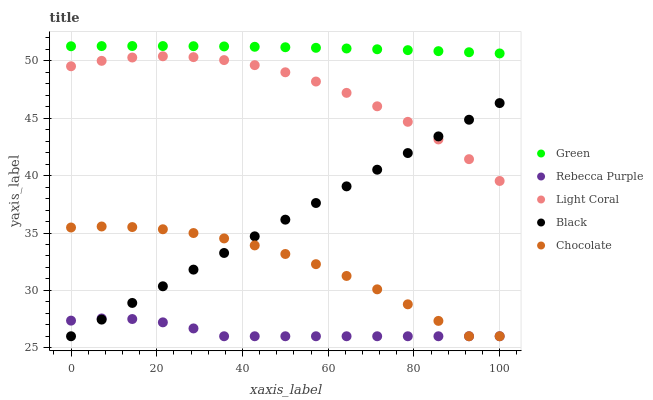Does Rebecca Purple have the minimum area under the curve?
Answer yes or no. Yes. Does Green have the maximum area under the curve?
Answer yes or no. Yes. Does Black have the minimum area under the curve?
Answer yes or no. No. Does Black have the maximum area under the curve?
Answer yes or no. No. Is Black the smoothest?
Answer yes or no. Yes. Is Chocolate the roughest?
Answer yes or no. Yes. Is Green the smoothest?
Answer yes or no. No. Is Green the roughest?
Answer yes or no. No. Does Black have the lowest value?
Answer yes or no. Yes. Does Green have the lowest value?
Answer yes or no. No. Does Green have the highest value?
Answer yes or no. Yes. Does Black have the highest value?
Answer yes or no. No. Is Black less than Green?
Answer yes or no. Yes. Is Green greater than Light Coral?
Answer yes or no. Yes. Does Chocolate intersect Rebecca Purple?
Answer yes or no. Yes. Is Chocolate less than Rebecca Purple?
Answer yes or no. No. Is Chocolate greater than Rebecca Purple?
Answer yes or no. No. Does Black intersect Green?
Answer yes or no. No. 